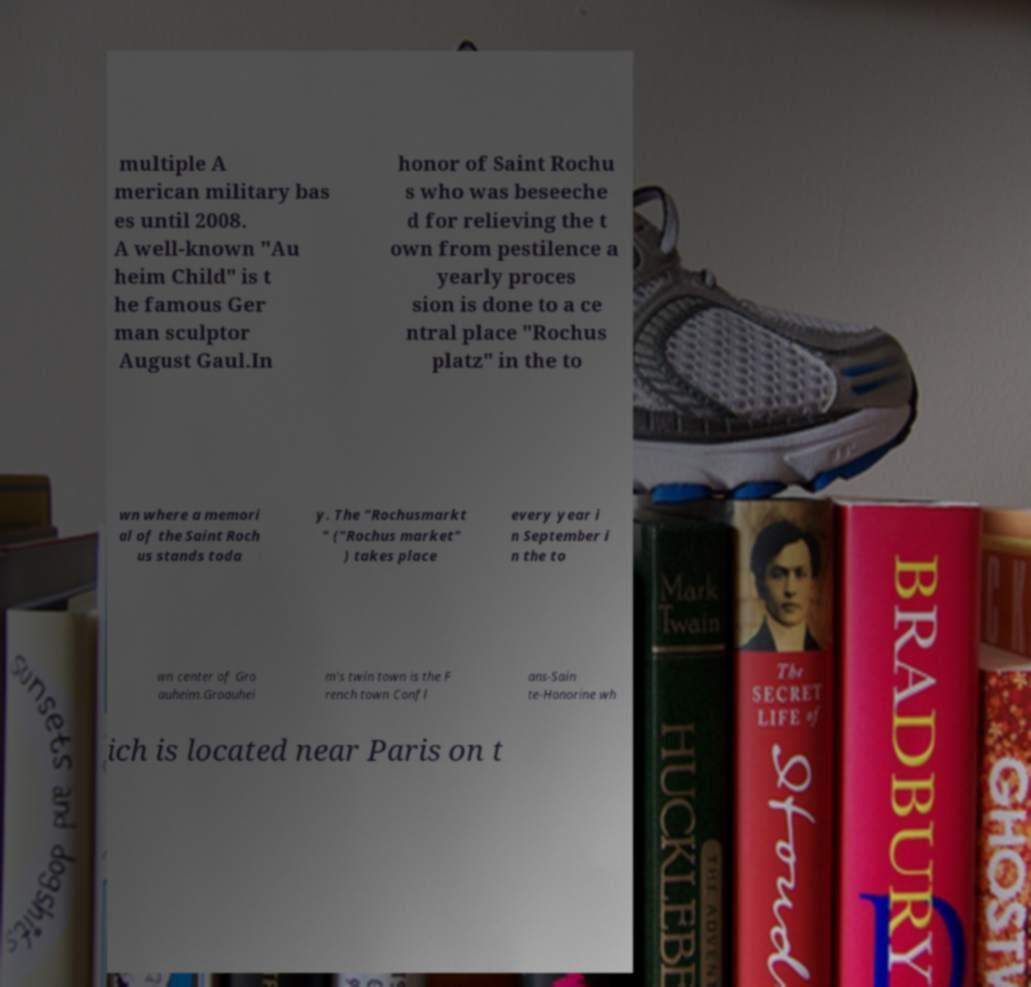Can you read and provide the text displayed in the image?This photo seems to have some interesting text. Can you extract and type it out for me? multiple A merican military bas es until 2008. A well-known "Au heim Child" is t he famous Ger man sculptor August Gaul.In honor of Saint Rochu s who was beseeche d for relieving the t own from pestilence a yearly proces sion is done to a ce ntral place "Rochus platz" in the to wn where a memori al of the Saint Roch us stands toda y. The "Rochusmarkt " ("Rochus market" ) takes place every year i n September i n the to wn center of Gro auheim.Groauhei m's twin town is the F rench town Confl ans-Sain te-Honorine wh ich is located near Paris on t 